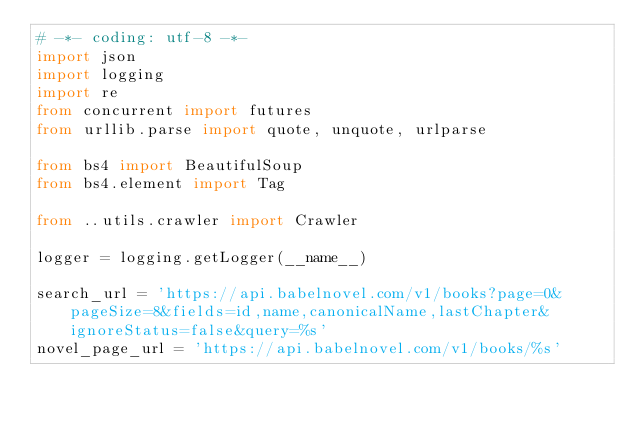<code> <loc_0><loc_0><loc_500><loc_500><_Python_># -*- coding: utf-8 -*-
import json
import logging
import re
from concurrent import futures
from urllib.parse import quote, unquote, urlparse

from bs4 import BeautifulSoup
from bs4.element import Tag

from ..utils.crawler import Crawler

logger = logging.getLogger(__name__)

search_url = 'https://api.babelnovel.com/v1/books?page=0&pageSize=8&fields=id,name,canonicalName,lastChapter&ignoreStatus=false&query=%s'
novel_page_url = 'https://api.babelnovel.com/v1/books/%s'</code> 